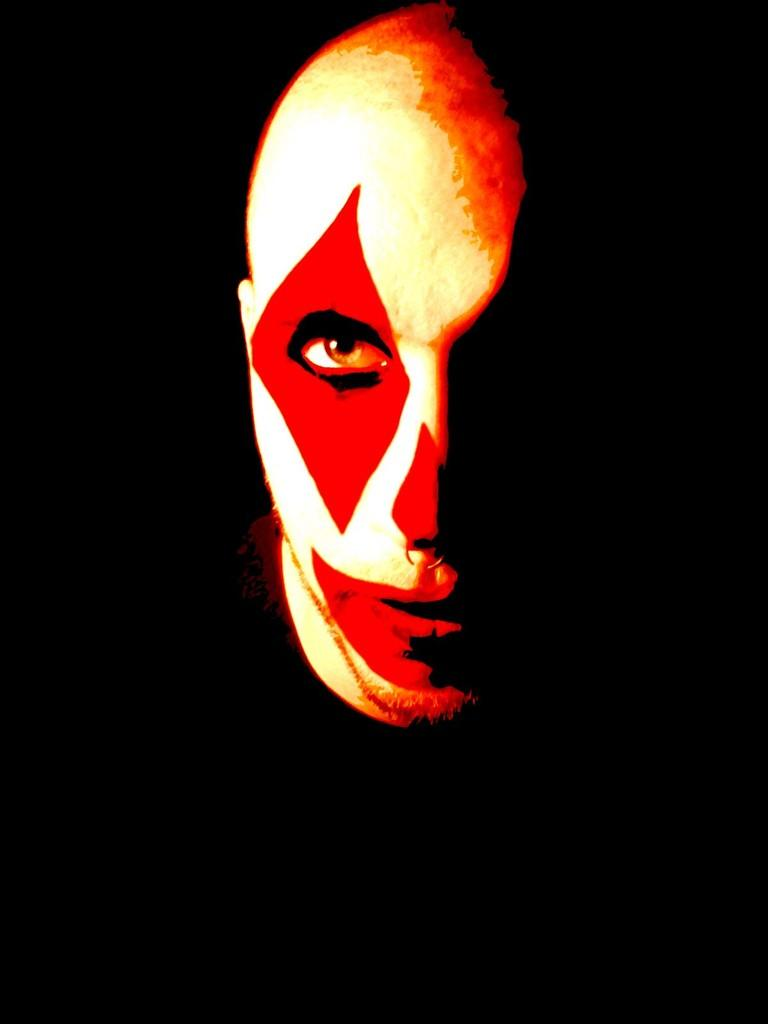What part of the person is visible in the image? The person's face is visible in the image. What colors can be seen on the person's face? The face has red, orange, and cream colors. What color is the background of the image? The background of the image is black. How many events are listed on the calendar in the image? There is no calendar present in the image. What type of collar is the person wearing in the image? The person's face is visible in the image, but there is no indication of a collar or any clothing. 